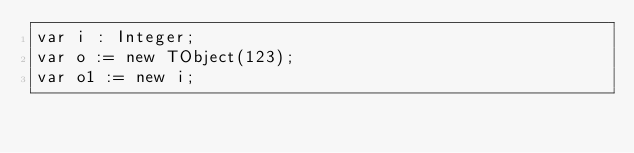<code> <loc_0><loc_0><loc_500><loc_500><_Pascal_>var i : Integer;
var o := new TObject(123);
var o1 := new i;
</code> 